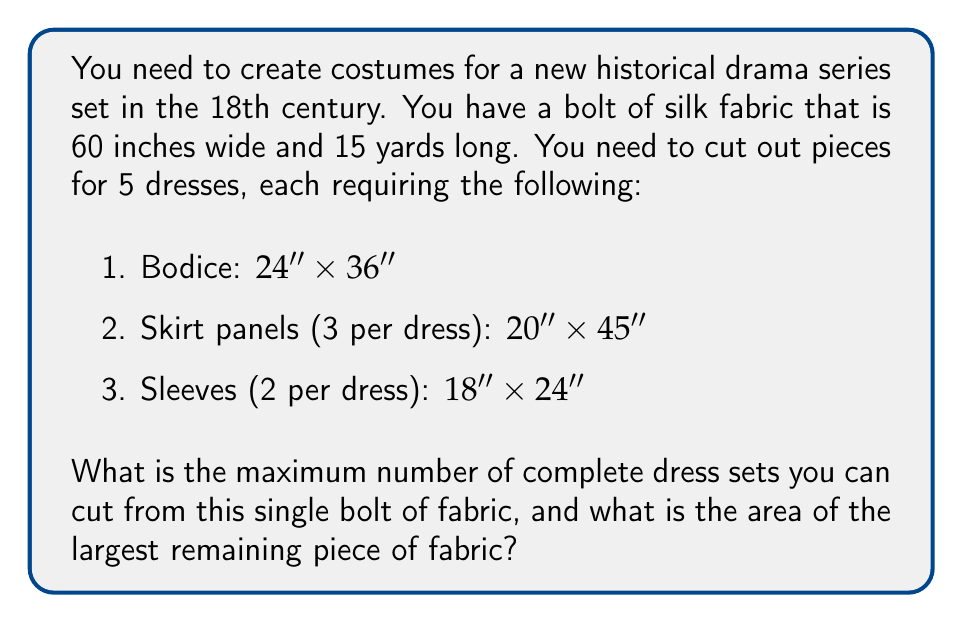Can you answer this question? To solve this problem, we need to follow these steps:

1. Calculate the total area of the fabric:
   $$60 \text{ inches} \times (15 \text{ yards} \times 36 \text{ inches/yard}) = 32,400 \text{ sq inches}$$

2. Calculate the area required for one complete dress set:
   - Bodice: $24" \times 36" = 864 \text{ sq inches}$
   - Skirt panels: $3 \times (20" \times 45") = 2,700 \text{ sq inches}$
   - Sleeves: $2 \times (18" \times 24") = 864 \text{ sq inches}$
   Total area per dress: $864 + 2,700 + 864 = 4,428 \text{ sq inches}$

3. Determine the maximum number of complete dress sets:
   $$\left\lfloor\frac{32,400}{4,428}\right\rfloor = 7 \text{ complete sets}$$

4. Calculate the remaining fabric area:
   $$32,400 - (7 \times 4,428) = 1,404 \text{ sq inches}$$

5. To find the largest remaining piece, we need to consider the fabric width (60") and optimize the cutting layout. The best approach is to cut the pieces in strips:

   - Bodice: 24" wide strip
   - Skirt panels: 20" wide strip
   - Sleeves: 18" wide strip

   This leaves a 2" wide strip unused along the length of the fabric.

6. After cutting 7 complete sets, the remaining fabric will be:
   $$60" \times \frac{1,404}{60} = 60" \times 23.4" \approx 60" \times 23"$$

Therefore, the largest remaining piece will be approximately 60" x 23".
Answer: The maximum number of complete dress sets that can be cut is 7, and the area of the largest remaining piece of fabric is approximately 1,380 sq inches (60" x 23"). 